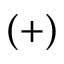Convert formula to latex. <formula><loc_0><loc_0><loc_500><loc_500>( + )</formula> 